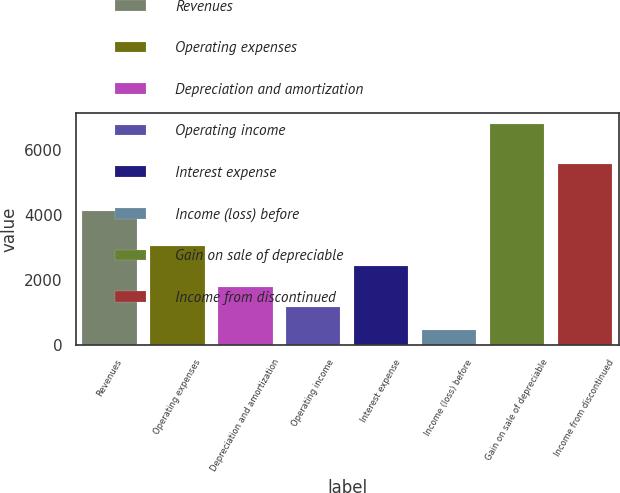Convert chart to OTSL. <chart><loc_0><loc_0><loc_500><loc_500><bar_chart><fcel>Revenues<fcel>Operating expenses<fcel>Depreciation and amortization<fcel>Operating income<fcel>Interest expense<fcel>Income (loss) before<fcel>Gain on sale of depreciable<fcel>Income from discontinued<nl><fcel>4115<fcel>3051.1<fcel>1781.7<fcel>1147<fcel>2416.4<fcel>439<fcel>6786<fcel>5575<nl></chart> 